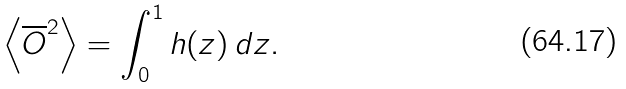<formula> <loc_0><loc_0><loc_500><loc_500>\left < \overline { O } ^ { 2 } \right > = \int _ { 0 } ^ { 1 } h ( z ) \, d z .</formula> 